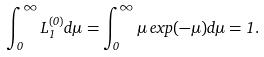Convert formula to latex. <formula><loc_0><loc_0><loc_500><loc_500>\int _ { 0 } ^ { \infty } L _ { 1 } ^ { ( 0 ) } d \mu = \int _ { 0 } ^ { \infty } \mu \, e x p ( - \mu ) d \mu = 1 .</formula> 